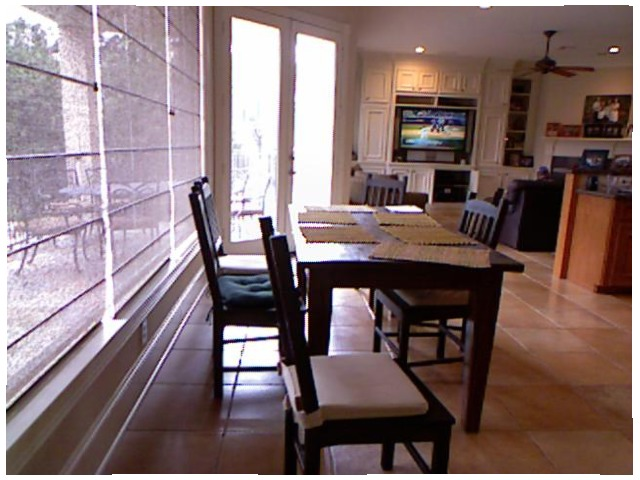<image>
Is there a chair in front of the window? Yes. The chair is positioned in front of the window, appearing closer to the camera viewpoint. Where is the chair in relation to the chair? Is it in front of the chair? No. The chair is not in front of the chair. The spatial positioning shows a different relationship between these objects. Is there a baseball player on the tv? Yes. Looking at the image, I can see the baseball player is positioned on top of the tv, with the tv providing support. Is there a cloth on the table? Yes. Looking at the image, I can see the cloth is positioned on top of the table, with the table providing support. Is the tv on the table? No. The tv is not positioned on the table. They may be near each other, but the tv is not supported by or resting on top of the table. Where is the table in relation to the chair? Is it behind the chair? No. The table is not behind the chair. From this viewpoint, the table appears to be positioned elsewhere in the scene. Is the chair to the left of the chair? No. The chair is not to the left of the chair. From this viewpoint, they have a different horizontal relationship. 